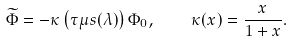<formula> <loc_0><loc_0><loc_500><loc_500>\widetilde { \Phi } = - \kappa \left ( \tau \mu s ( \lambda ) \right ) \Phi _ { 0 } , \quad \kappa ( x ) = \frac { x } { 1 + x } .</formula> 